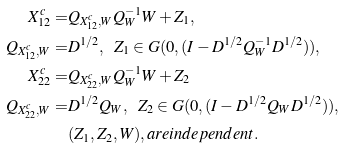<formula> <loc_0><loc_0><loc_500><loc_500>X _ { 1 2 } ^ { c } = & Q _ { X _ { 1 2 } ^ { c } , W } Q _ { W } ^ { - 1 } W + Z _ { 1 } , \\ Q _ { X _ { 1 2 } ^ { c } , W } = & D ^ { 1 / 2 } , \ \ Z _ { 1 } \in G ( 0 , ( I - D ^ { 1 / 2 } Q _ { W } ^ { - 1 } D ^ { 1 / 2 } ) ) , \\ X _ { 2 2 } ^ { c } = & Q _ { X _ { 2 2 } ^ { c } , W } Q _ { W } ^ { - 1 } W + Z _ { 2 } \\ Q _ { X _ { 2 2 } ^ { c } , W } = & D ^ { 1 / 2 } Q _ { W } , \ \ Z _ { 2 } \in G ( 0 , ( I - D ^ { 1 / 2 } Q _ { W } D ^ { 1 / 2 } ) ) , \\ & ( Z _ { 1 } , Z _ { 2 } , W ) , a r e i n d e p e n d e n t .</formula> 